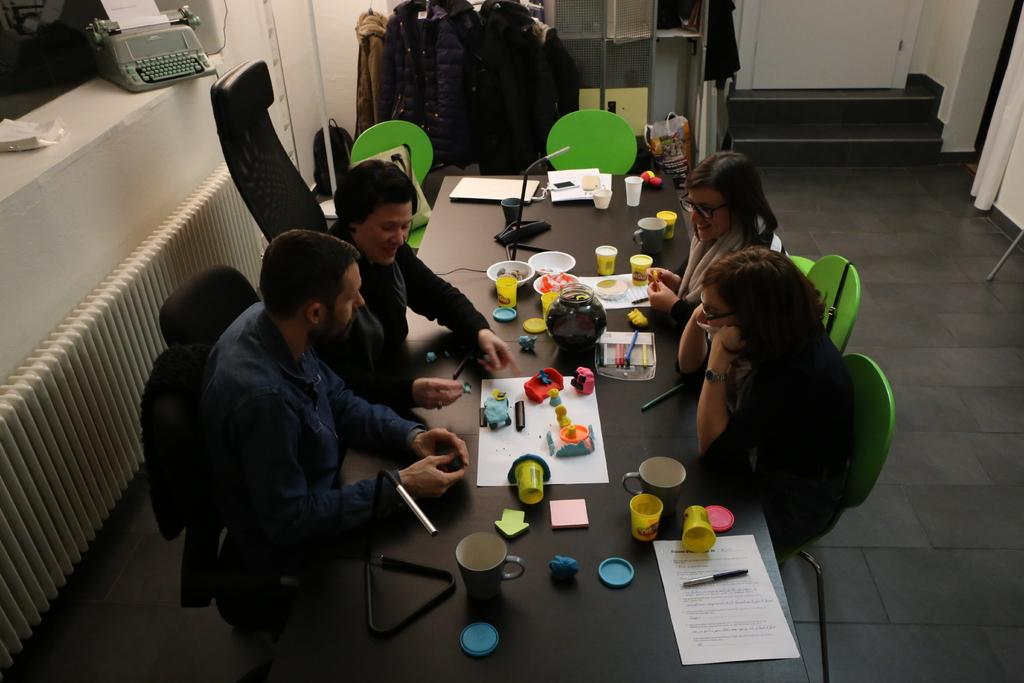What are the people in the image doing? There is a group of people sitting on chairs in the image. What is in front of the group of people? There is a table in front of the group of people. What is on the table? There are papers and objects on the table. What type of clothing can be seen in the image? There are jackets in the image. What is the background of the image? There is a wall in the image. What type of popcorn is being served to the group of people in the image? There is no popcorn present in the image. What question is being asked by the person in the image? There is no person asking a question in the image. 